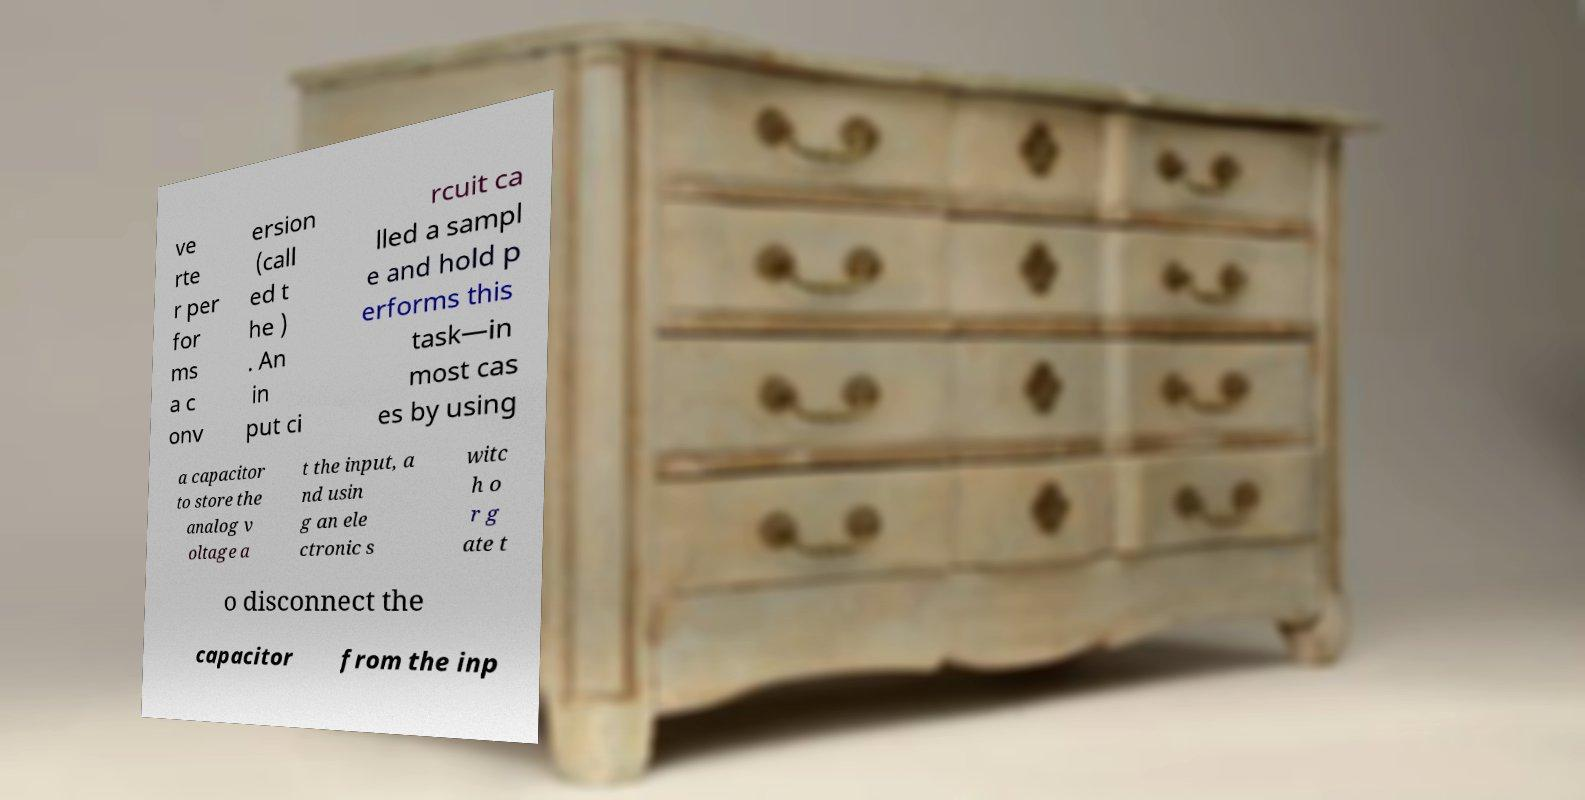Please read and relay the text visible in this image. What does it say? ve rte r per for ms a c onv ersion (call ed t he ) . An in put ci rcuit ca lled a sampl e and hold p erforms this task—in most cas es by using a capacitor to store the analog v oltage a t the input, a nd usin g an ele ctronic s witc h o r g ate t o disconnect the capacitor from the inp 